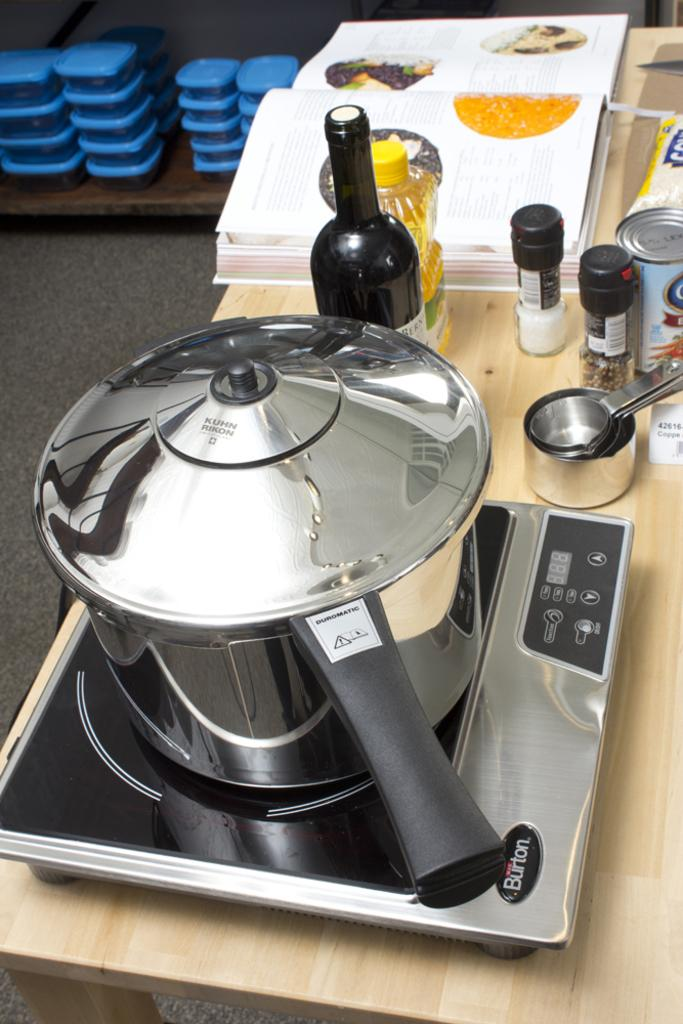Provide a one-sentence caption for the provided image. A Duromatic pressure cooker sits on a burner near some ingredients and an open recipe book. 